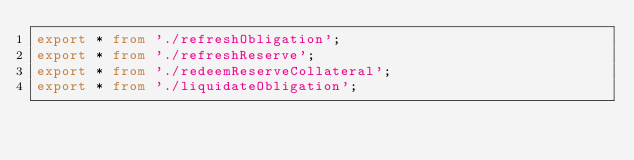Convert code to text. <code><loc_0><loc_0><loc_500><loc_500><_TypeScript_>export * from './refreshObligation';
export * from './refreshReserve';
export * from './redeemReserveCollateral';
export * from './liquidateObligation';
</code> 